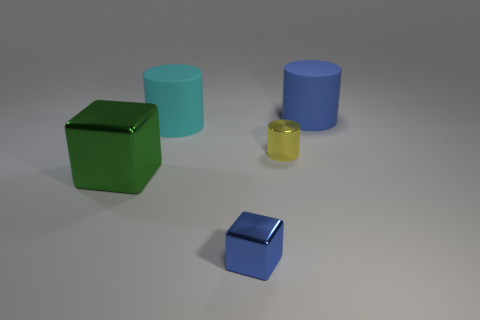Subtract all large cyan rubber cylinders. How many cylinders are left? 2 Add 4 yellow cylinders. How many objects exist? 9 Subtract all cyan cylinders. How many cylinders are left? 2 Subtract all cylinders. How many objects are left? 2 Subtract all red cylinders. Subtract all purple blocks. How many cylinders are left? 3 Subtract all large cyan things. Subtract all large green shiny things. How many objects are left? 3 Add 4 large green cubes. How many large green cubes are left? 5 Add 5 purple blocks. How many purple blocks exist? 5 Subtract 0 blue spheres. How many objects are left? 5 